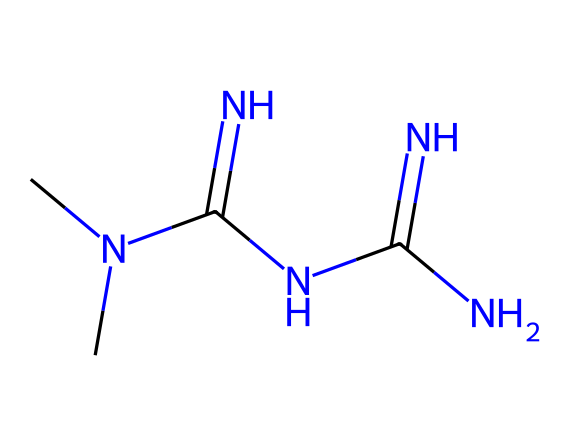What is the molecular formula of metformin? The SMILES representation provides the necessary information to deduce the molecular formula. Counting the constituent atoms, we have 4 carbon (C) atoms, 11 hydrogen (H) atoms, 5 nitrogen (N) atoms, and no oxygen (O) atoms. Therefore, the molecular formula is C4H11N5.
Answer: C4H11N5 How many nitrogen atoms are present in metformin? In the SMILES representation, each 'N' indicates a nitrogen atom. Counting the 'N' symbols present in the structure shows there are 5 nitrogen atoms.
Answer: 5 What type of molecular structure does metformin represent? The SMILES representation indicates a complex molecule with multiple nitrogen components, typical of biguanides, which are known for their use in treating diabetes. This class of compounds possesses a specific configuration that influences its biological activity.
Answer: biguanide What role does metformin play in glucose metabolism? Metformin is primarily known to decrease hepatic glucose production, increase insulin sensitivity, and enhance glucose uptake in peripheral tissues. This is essential for its mechanism in managing diabetes effectively.
Answer: lowers blood sugar Which part of the metformin structure indicates its biological activity? The presence of multiple nitrogen atoms connected with carbon skeletons suggests its interaction with biological targets, particularly in influencing insulin action, which is crucial for its anti-diabetic properties.
Answer: nitrogen atoms How many carbon atoms are in the metformin molecule? The SMILES notation reveals four 'C' atoms present in the molecular structure. Therefore, we find that metformin contains four carbon atoms.
Answer: 4 What is the functional effect of metformin in diabetic patients? Metformin primarily works by enhancing insulin sensitivity and reducing glucose production. This makes it a first-line medication for type 2 diabetes management, significantly impacting the blood glucose levels of patients.
Answer: enhances insulin sensitivity 